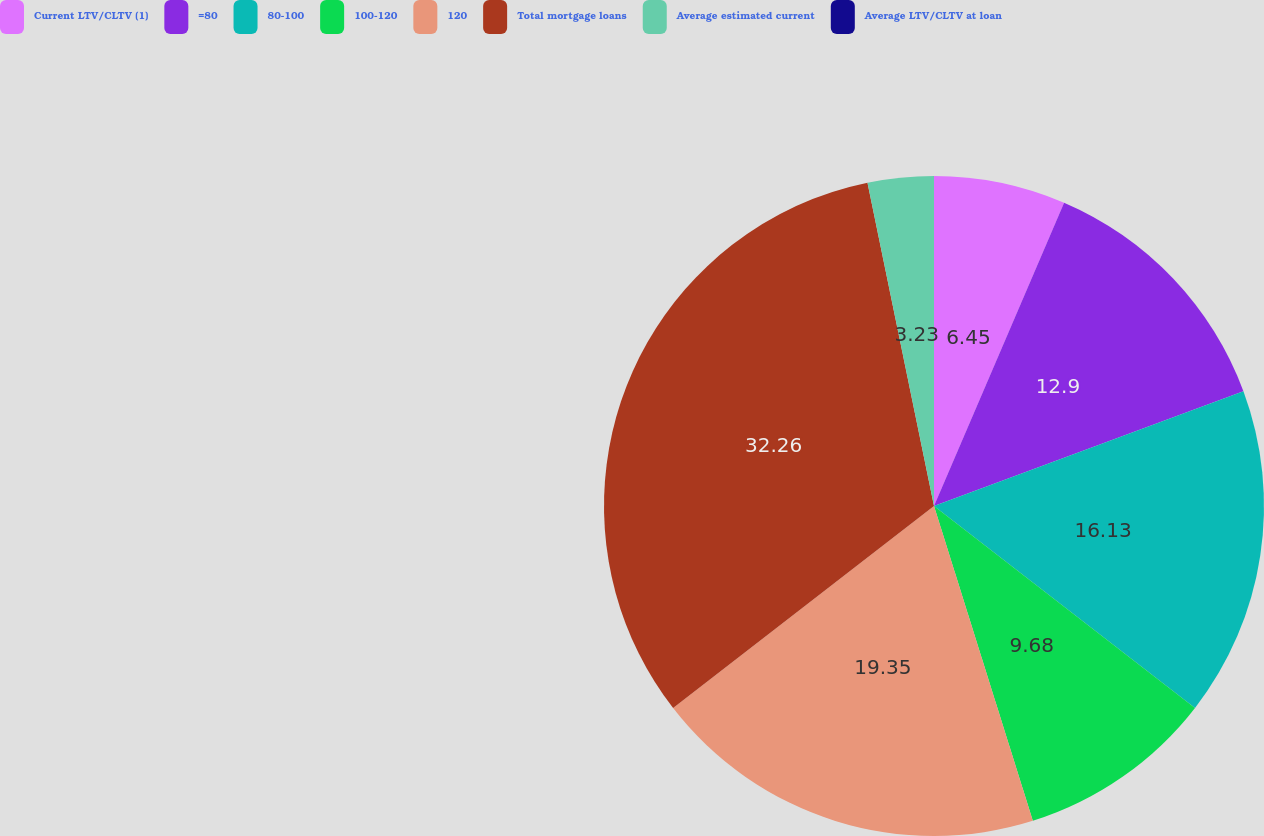Convert chart. <chart><loc_0><loc_0><loc_500><loc_500><pie_chart><fcel>Current LTV/CLTV (1)<fcel>=80<fcel>80-100<fcel>100-120<fcel>120<fcel>Total mortgage loans<fcel>Average estimated current<fcel>Average LTV/CLTV at loan<nl><fcel>6.45%<fcel>12.9%<fcel>16.13%<fcel>9.68%<fcel>19.35%<fcel>32.26%<fcel>3.23%<fcel>0.0%<nl></chart> 